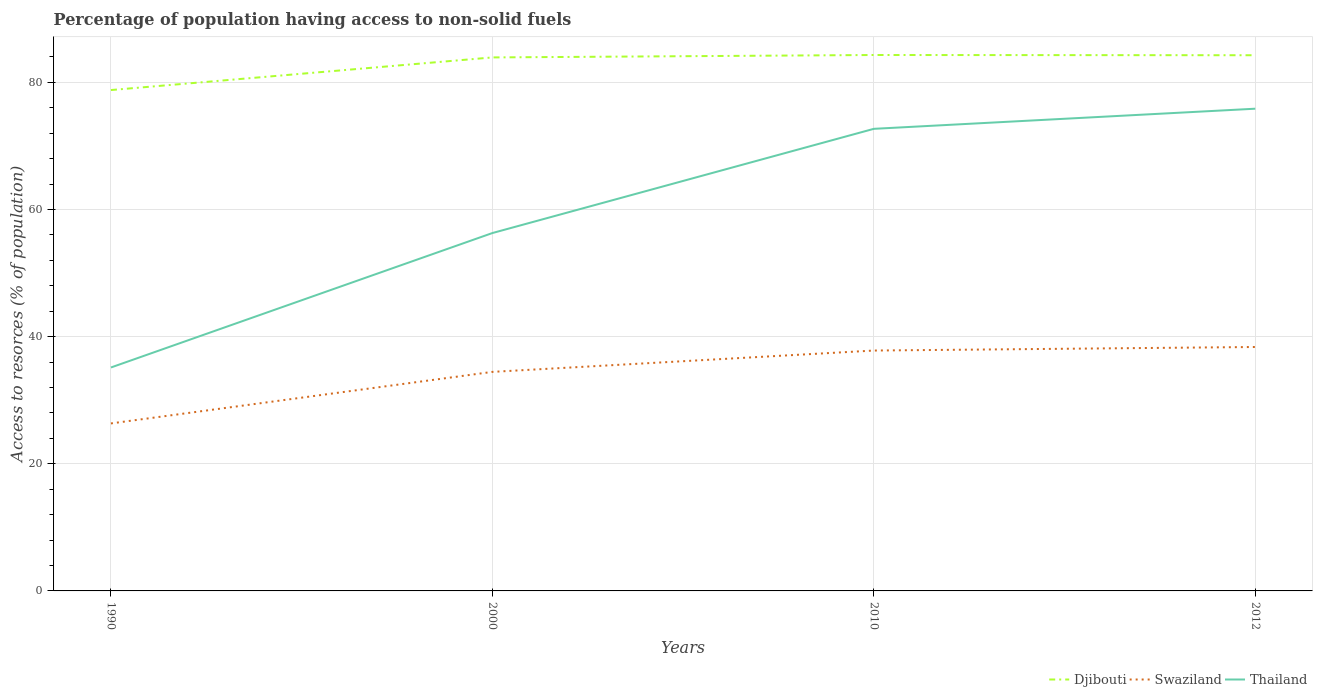How many different coloured lines are there?
Give a very brief answer. 3. Is the number of lines equal to the number of legend labels?
Your answer should be compact. Yes. Across all years, what is the maximum percentage of population having access to non-solid fuels in Djibouti?
Give a very brief answer. 78.8. In which year was the percentage of population having access to non-solid fuels in Swaziland maximum?
Offer a very short reply. 1990. What is the total percentage of population having access to non-solid fuels in Djibouti in the graph?
Offer a terse response. -0.34. What is the difference between the highest and the second highest percentage of population having access to non-solid fuels in Djibouti?
Give a very brief answer. 5.51. Is the percentage of population having access to non-solid fuels in Thailand strictly greater than the percentage of population having access to non-solid fuels in Swaziland over the years?
Make the answer very short. No. What is the difference between two consecutive major ticks on the Y-axis?
Provide a short and direct response. 20. Are the values on the major ticks of Y-axis written in scientific E-notation?
Offer a terse response. No. Does the graph contain any zero values?
Your answer should be very brief. No. How many legend labels are there?
Give a very brief answer. 3. What is the title of the graph?
Offer a very short reply. Percentage of population having access to non-solid fuels. Does "France" appear as one of the legend labels in the graph?
Offer a very short reply. No. What is the label or title of the X-axis?
Provide a succinct answer. Years. What is the label or title of the Y-axis?
Give a very brief answer. Access to resorces (% of population). What is the Access to resorces (% of population) in Djibouti in 1990?
Your answer should be very brief. 78.8. What is the Access to resorces (% of population) of Swaziland in 1990?
Make the answer very short. 26.35. What is the Access to resorces (% of population) of Thailand in 1990?
Provide a short and direct response. 35.15. What is the Access to resorces (% of population) of Djibouti in 2000?
Provide a succinct answer. 83.93. What is the Access to resorces (% of population) in Swaziland in 2000?
Give a very brief answer. 34.46. What is the Access to resorces (% of population) in Thailand in 2000?
Ensure brevity in your answer.  56.3. What is the Access to resorces (% of population) in Djibouti in 2010?
Make the answer very short. 84.31. What is the Access to resorces (% of population) of Swaziland in 2010?
Your response must be concise. 37.82. What is the Access to resorces (% of population) of Thailand in 2010?
Provide a succinct answer. 72.7. What is the Access to resorces (% of population) in Djibouti in 2012?
Your answer should be very brief. 84.27. What is the Access to resorces (% of population) in Swaziland in 2012?
Provide a succinct answer. 38.37. What is the Access to resorces (% of population) of Thailand in 2012?
Your response must be concise. 75.86. Across all years, what is the maximum Access to resorces (% of population) in Djibouti?
Give a very brief answer. 84.31. Across all years, what is the maximum Access to resorces (% of population) in Swaziland?
Your answer should be compact. 38.37. Across all years, what is the maximum Access to resorces (% of population) of Thailand?
Provide a succinct answer. 75.86. Across all years, what is the minimum Access to resorces (% of population) in Djibouti?
Your response must be concise. 78.8. Across all years, what is the minimum Access to resorces (% of population) of Swaziland?
Your answer should be compact. 26.35. Across all years, what is the minimum Access to resorces (% of population) in Thailand?
Give a very brief answer. 35.15. What is the total Access to resorces (% of population) of Djibouti in the graph?
Give a very brief answer. 331.31. What is the total Access to resorces (% of population) of Swaziland in the graph?
Provide a short and direct response. 137. What is the total Access to resorces (% of population) of Thailand in the graph?
Provide a succinct answer. 240.01. What is the difference between the Access to resorces (% of population) of Djibouti in 1990 and that in 2000?
Your answer should be compact. -5.13. What is the difference between the Access to resorces (% of population) in Swaziland in 1990 and that in 2000?
Make the answer very short. -8.11. What is the difference between the Access to resorces (% of population) in Thailand in 1990 and that in 2000?
Your answer should be very brief. -21.15. What is the difference between the Access to resorces (% of population) of Djibouti in 1990 and that in 2010?
Ensure brevity in your answer.  -5.51. What is the difference between the Access to resorces (% of population) of Swaziland in 1990 and that in 2010?
Provide a short and direct response. -11.47. What is the difference between the Access to resorces (% of population) in Thailand in 1990 and that in 2010?
Offer a very short reply. -37.54. What is the difference between the Access to resorces (% of population) of Djibouti in 1990 and that in 2012?
Offer a terse response. -5.48. What is the difference between the Access to resorces (% of population) in Swaziland in 1990 and that in 2012?
Offer a terse response. -12.02. What is the difference between the Access to resorces (% of population) of Thailand in 1990 and that in 2012?
Give a very brief answer. -40.71. What is the difference between the Access to resorces (% of population) in Djibouti in 2000 and that in 2010?
Ensure brevity in your answer.  -0.38. What is the difference between the Access to resorces (% of population) of Swaziland in 2000 and that in 2010?
Offer a terse response. -3.36. What is the difference between the Access to resorces (% of population) in Thailand in 2000 and that in 2010?
Give a very brief answer. -16.39. What is the difference between the Access to resorces (% of population) of Djibouti in 2000 and that in 2012?
Provide a succinct answer. -0.34. What is the difference between the Access to resorces (% of population) in Swaziland in 2000 and that in 2012?
Provide a succinct answer. -3.91. What is the difference between the Access to resorces (% of population) of Thailand in 2000 and that in 2012?
Ensure brevity in your answer.  -19.56. What is the difference between the Access to resorces (% of population) in Djibouti in 2010 and that in 2012?
Provide a short and direct response. 0.04. What is the difference between the Access to resorces (% of population) of Swaziland in 2010 and that in 2012?
Provide a succinct answer. -0.56. What is the difference between the Access to resorces (% of population) of Thailand in 2010 and that in 2012?
Keep it short and to the point. -3.17. What is the difference between the Access to resorces (% of population) of Djibouti in 1990 and the Access to resorces (% of population) of Swaziland in 2000?
Offer a very short reply. 44.34. What is the difference between the Access to resorces (% of population) of Djibouti in 1990 and the Access to resorces (% of population) of Thailand in 2000?
Your answer should be very brief. 22.5. What is the difference between the Access to resorces (% of population) in Swaziland in 1990 and the Access to resorces (% of population) in Thailand in 2000?
Offer a terse response. -29.95. What is the difference between the Access to resorces (% of population) in Djibouti in 1990 and the Access to resorces (% of population) in Swaziland in 2010?
Ensure brevity in your answer.  40.98. What is the difference between the Access to resorces (% of population) of Djibouti in 1990 and the Access to resorces (% of population) of Thailand in 2010?
Make the answer very short. 6.1. What is the difference between the Access to resorces (% of population) of Swaziland in 1990 and the Access to resorces (% of population) of Thailand in 2010?
Give a very brief answer. -46.34. What is the difference between the Access to resorces (% of population) in Djibouti in 1990 and the Access to resorces (% of population) in Swaziland in 2012?
Provide a succinct answer. 40.42. What is the difference between the Access to resorces (% of population) of Djibouti in 1990 and the Access to resorces (% of population) of Thailand in 2012?
Give a very brief answer. 2.93. What is the difference between the Access to resorces (% of population) in Swaziland in 1990 and the Access to resorces (% of population) in Thailand in 2012?
Ensure brevity in your answer.  -49.51. What is the difference between the Access to resorces (% of population) of Djibouti in 2000 and the Access to resorces (% of population) of Swaziland in 2010?
Provide a succinct answer. 46.11. What is the difference between the Access to resorces (% of population) of Djibouti in 2000 and the Access to resorces (% of population) of Thailand in 2010?
Offer a very short reply. 11.23. What is the difference between the Access to resorces (% of population) in Swaziland in 2000 and the Access to resorces (% of population) in Thailand in 2010?
Provide a short and direct response. -38.23. What is the difference between the Access to resorces (% of population) of Djibouti in 2000 and the Access to resorces (% of population) of Swaziland in 2012?
Your response must be concise. 45.55. What is the difference between the Access to resorces (% of population) in Djibouti in 2000 and the Access to resorces (% of population) in Thailand in 2012?
Give a very brief answer. 8.07. What is the difference between the Access to resorces (% of population) of Swaziland in 2000 and the Access to resorces (% of population) of Thailand in 2012?
Make the answer very short. -41.4. What is the difference between the Access to resorces (% of population) in Djibouti in 2010 and the Access to resorces (% of population) in Swaziland in 2012?
Your answer should be compact. 45.94. What is the difference between the Access to resorces (% of population) in Djibouti in 2010 and the Access to resorces (% of population) in Thailand in 2012?
Your response must be concise. 8.45. What is the difference between the Access to resorces (% of population) in Swaziland in 2010 and the Access to resorces (% of population) in Thailand in 2012?
Ensure brevity in your answer.  -38.05. What is the average Access to resorces (% of population) in Djibouti per year?
Offer a terse response. 82.83. What is the average Access to resorces (% of population) of Swaziland per year?
Provide a succinct answer. 34.25. What is the average Access to resorces (% of population) in Thailand per year?
Keep it short and to the point. 60. In the year 1990, what is the difference between the Access to resorces (% of population) in Djibouti and Access to resorces (% of population) in Swaziland?
Offer a very short reply. 52.45. In the year 1990, what is the difference between the Access to resorces (% of population) in Djibouti and Access to resorces (% of population) in Thailand?
Ensure brevity in your answer.  43.65. In the year 1990, what is the difference between the Access to resorces (% of population) of Swaziland and Access to resorces (% of population) of Thailand?
Your answer should be very brief. -8.8. In the year 2000, what is the difference between the Access to resorces (% of population) of Djibouti and Access to resorces (% of population) of Swaziland?
Your answer should be compact. 49.47. In the year 2000, what is the difference between the Access to resorces (% of population) in Djibouti and Access to resorces (% of population) in Thailand?
Offer a very short reply. 27.63. In the year 2000, what is the difference between the Access to resorces (% of population) of Swaziland and Access to resorces (% of population) of Thailand?
Ensure brevity in your answer.  -21.84. In the year 2010, what is the difference between the Access to resorces (% of population) in Djibouti and Access to resorces (% of population) in Swaziland?
Your response must be concise. 46.49. In the year 2010, what is the difference between the Access to resorces (% of population) in Djibouti and Access to resorces (% of population) in Thailand?
Provide a short and direct response. 11.62. In the year 2010, what is the difference between the Access to resorces (% of population) in Swaziland and Access to resorces (% of population) in Thailand?
Offer a very short reply. -34.88. In the year 2012, what is the difference between the Access to resorces (% of population) of Djibouti and Access to resorces (% of population) of Swaziland?
Provide a short and direct response. 45.9. In the year 2012, what is the difference between the Access to resorces (% of population) in Djibouti and Access to resorces (% of population) in Thailand?
Offer a very short reply. 8.41. In the year 2012, what is the difference between the Access to resorces (% of population) of Swaziland and Access to resorces (% of population) of Thailand?
Provide a short and direct response. -37.49. What is the ratio of the Access to resorces (% of population) of Djibouti in 1990 to that in 2000?
Provide a succinct answer. 0.94. What is the ratio of the Access to resorces (% of population) in Swaziland in 1990 to that in 2000?
Offer a terse response. 0.76. What is the ratio of the Access to resorces (% of population) of Thailand in 1990 to that in 2000?
Your answer should be very brief. 0.62. What is the ratio of the Access to resorces (% of population) in Djibouti in 1990 to that in 2010?
Offer a terse response. 0.93. What is the ratio of the Access to resorces (% of population) in Swaziland in 1990 to that in 2010?
Keep it short and to the point. 0.7. What is the ratio of the Access to resorces (% of population) in Thailand in 1990 to that in 2010?
Give a very brief answer. 0.48. What is the ratio of the Access to resorces (% of population) of Djibouti in 1990 to that in 2012?
Make the answer very short. 0.94. What is the ratio of the Access to resorces (% of population) in Swaziland in 1990 to that in 2012?
Your response must be concise. 0.69. What is the ratio of the Access to resorces (% of population) in Thailand in 1990 to that in 2012?
Provide a succinct answer. 0.46. What is the ratio of the Access to resorces (% of population) in Djibouti in 2000 to that in 2010?
Provide a short and direct response. 1. What is the ratio of the Access to resorces (% of population) of Swaziland in 2000 to that in 2010?
Offer a terse response. 0.91. What is the ratio of the Access to resorces (% of population) of Thailand in 2000 to that in 2010?
Provide a succinct answer. 0.77. What is the ratio of the Access to resorces (% of population) of Djibouti in 2000 to that in 2012?
Offer a terse response. 1. What is the ratio of the Access to resorces (% of population) of Swaziland in 2000 to that in 2012?
Ensure brevity in your answer.  0.9. What is the ratio of the Access to resorces (% of population) in Thailand in 2000 to that in 2012?
Give a very brief answer. 0.74. What is the ratio of the Access to resorces (% of population) of Swaziland in 2010 to that in 2012?
Give a very brief answer. 0.99. What is the difference between the highest and the second highest Access to resorces (% of population) of Djibouti?
Provide a short and direct response. 0.04. What is the difference between the highest and the second highest Access to resorces (% of population) of Swaziland?
Give a very brief answer. 0.56. What is the difference between the highest and the second highest Access to resorces (% of population) in Thailand?
Offer a terse response. 3.17. What is the difference between the highest and the lowest Access to resorces (% of population) in Djibouti?
Provide a short and direct response. 5.51. What is the difference between the highest and the lowest Access to resorces (% of population) in Swaziland?
Ensure brevity in your answer.  12.02. What is the difference between the highest and the lowest Access to resorces (% of population) of Thailand?
Ensure brevity in your answer.  40.71. 